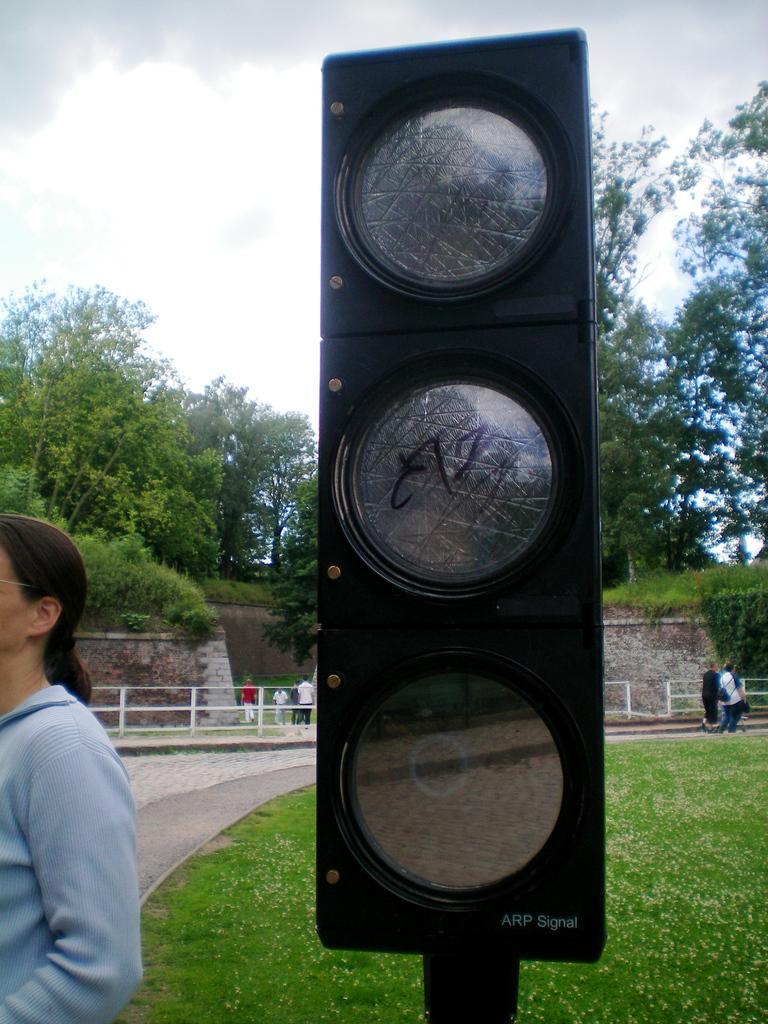Please provide a concise description of this image. In this image there are traffic signal lights in the middle. On the ground there is grass. On the left side there is a woman. In the background there is a way on which there are two persons. At the top there is the sky. In the background there are trees. 